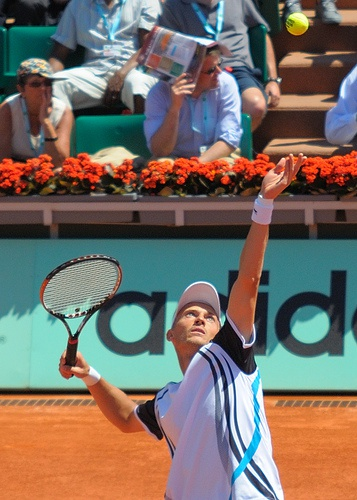Describe the objects in this image and their specific colors. I can see people in black, gray, white, and brown tones, potted plant in black, maroon, gray, and red tones, people in black, gray, maroon, and lavender tones, people in black, lightgray, gray, and darkgray tones, and people in black, darkgray, and gray tones in this image. 